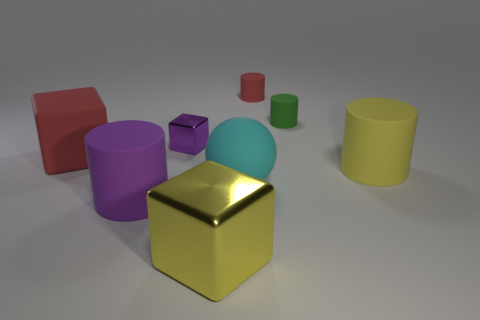Is there a purple object of the same size as the green matte thing?
Keep it short and to the point. Yes. There is a large matte thing behind the large cylinder that is on the right side of the small red matte cylinder that is behind the big red thing; what color is it?
Give a very brief answer. Red. Is the material of the big cyan object the same as the large cylinder on the right side of the big metallic thing?
Keep it short and to the point. Yes. There is a green object that is the same shape as the small red object; what is its size?
Ensure brevity in your answer.  Small. Are there an equal number of purple matte cylinders that are behind the big cyan rubber thing and yellow cubes behind the large yellow shiny object?
Make the answer very short. Yes. How many other objects are there of the same material as the tiny red cylinder?
Make the answer very short. 5. Is the number of tiny metal things that are in front of the red block the same as the number of red matte spheres?
Offer a very short reply. Yes. Do the rubber sphere and the red object that is to the right of the large yellow metal thing have the same size?
Your answer should be very brief. No. There is a red matte object to the right of the big yellow shiny object; what shape is it?
Keep it short and to the point. Cylinder. Is there any other thing that is the same shape as the big red thing?
Offer a terse response. Yes. 